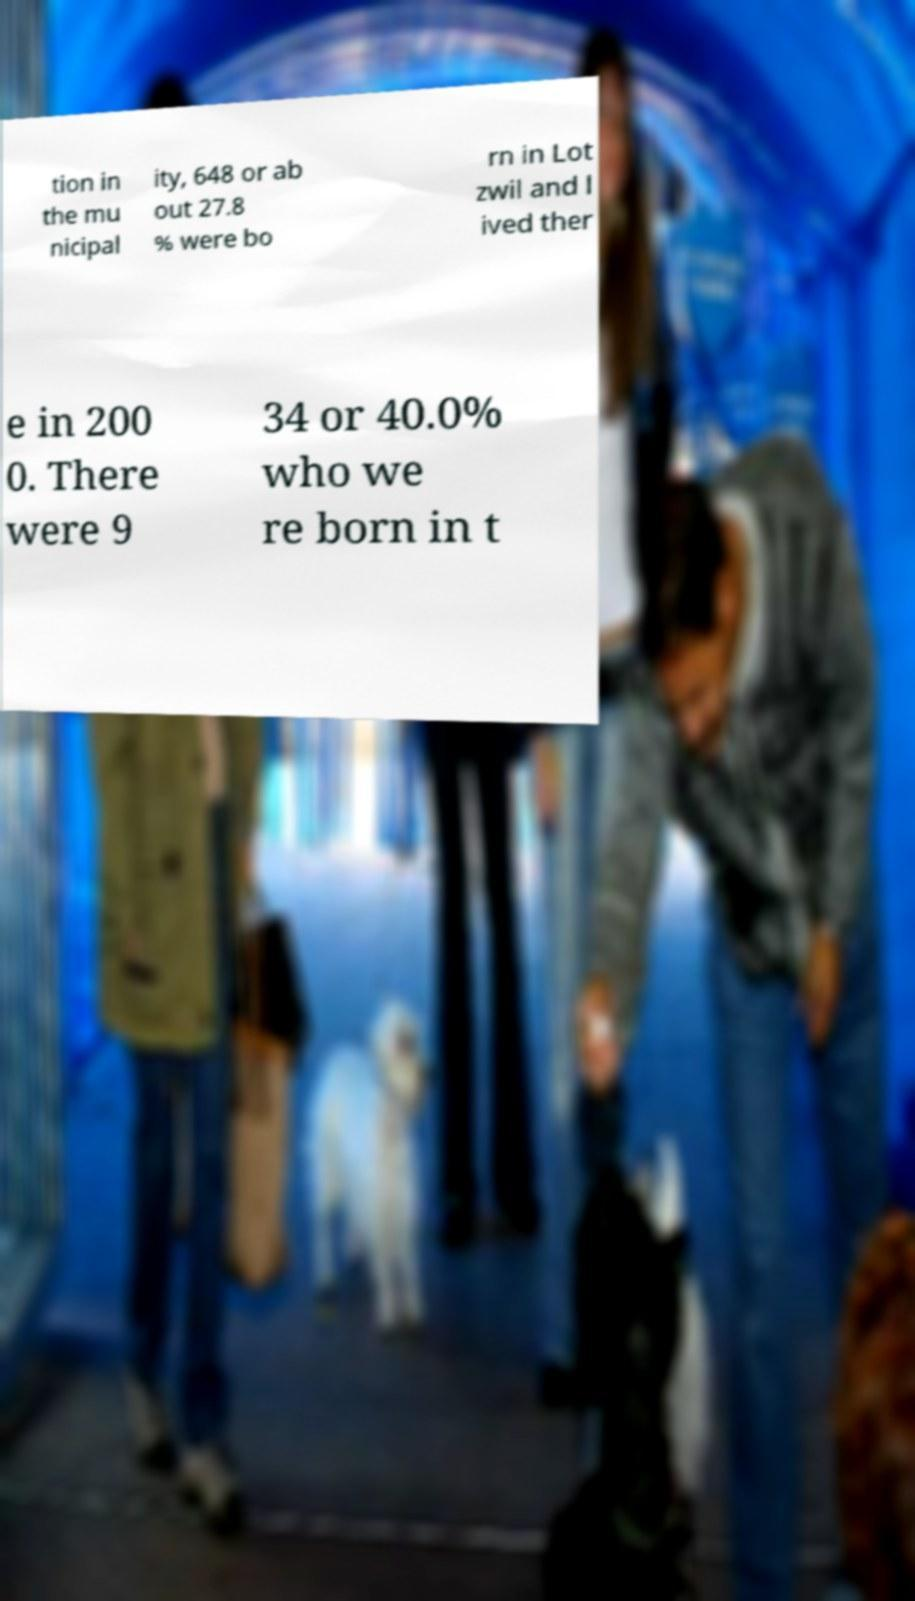Could you extract and type out the text from this image? tion in the mu nicipal ity, 648 or ab out 27.8 % were bo rn in Lot zwil and l ived ther e in 200 0. There were 9 34 or 40.0% who we re born in t 